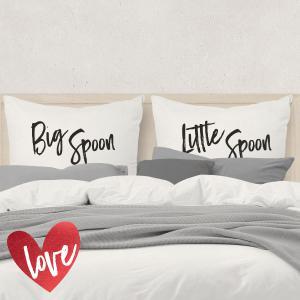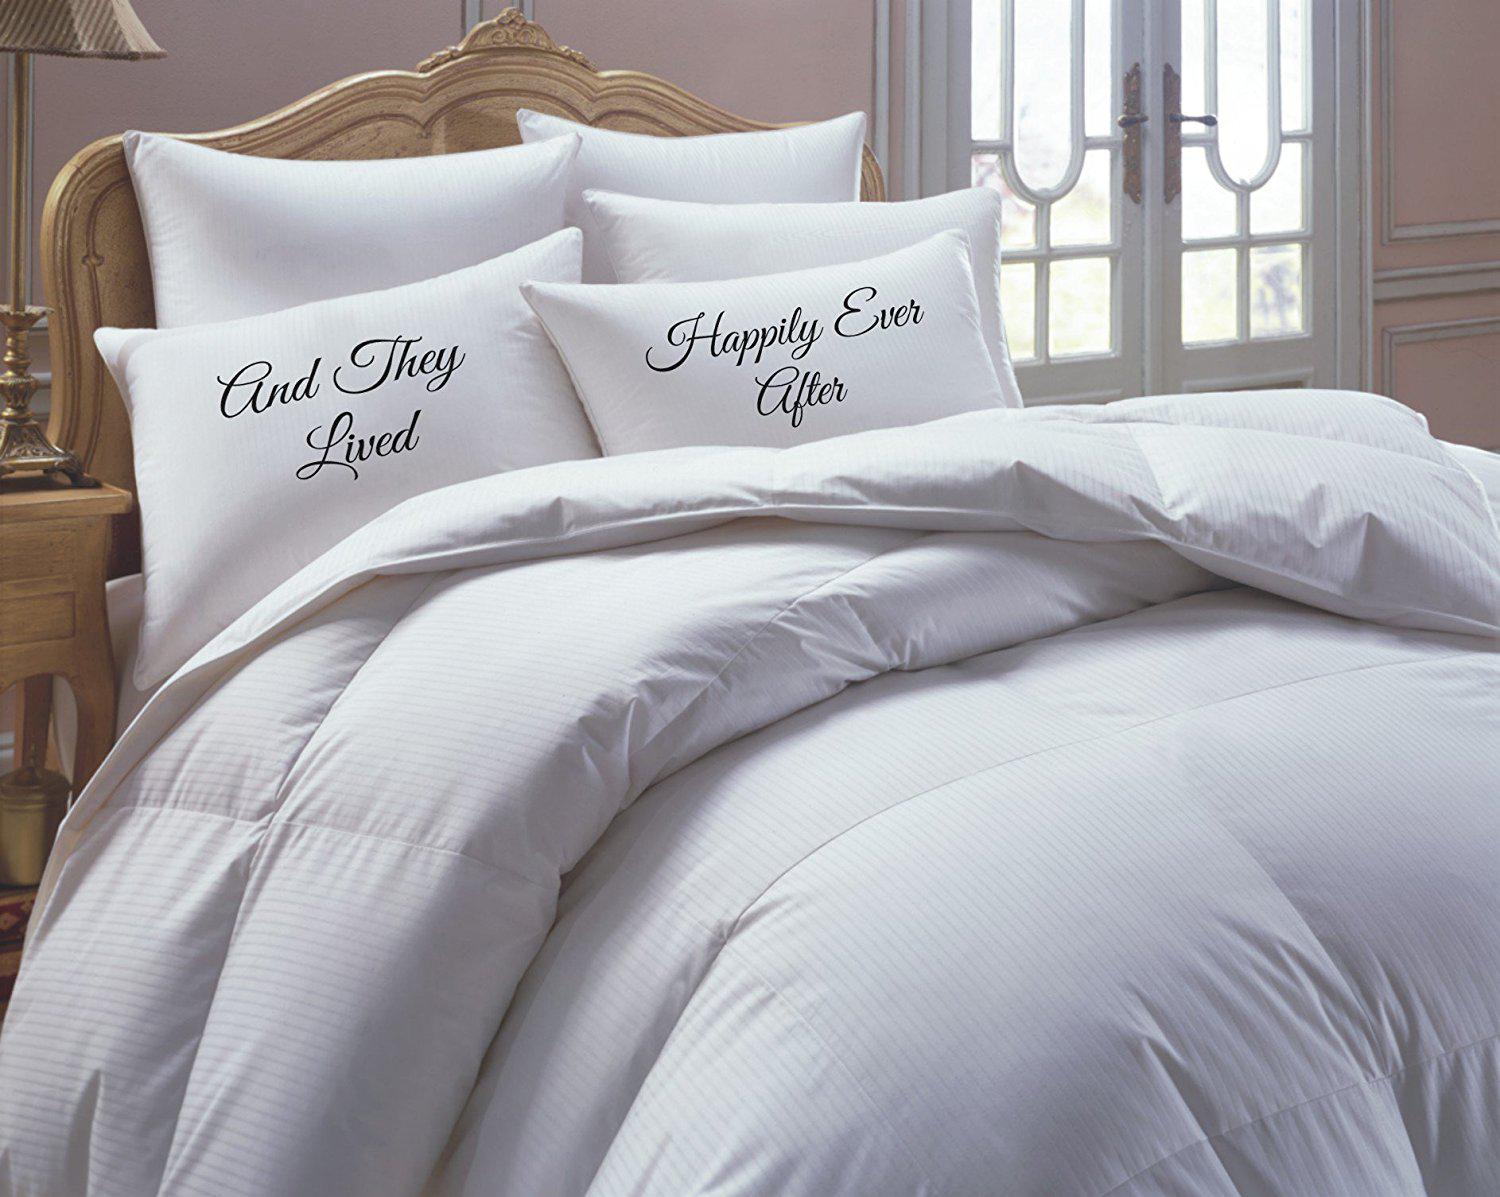The first image is the image on the left, the second image is the image on the right. Considering the images on both sides, is "Pillows in both of the images have words written on them." valid? Answer yes or no. Yes. The first image is the image on the left, the second image is the image on the right. Evaluate the accuracy of this statement regarding the images: "The right image shows a bed with a white comforter and side-by-side white pillows printed with non-cursive dark letters, propped atop plain white pillows.". Is it true? Answer yes or no. No. 